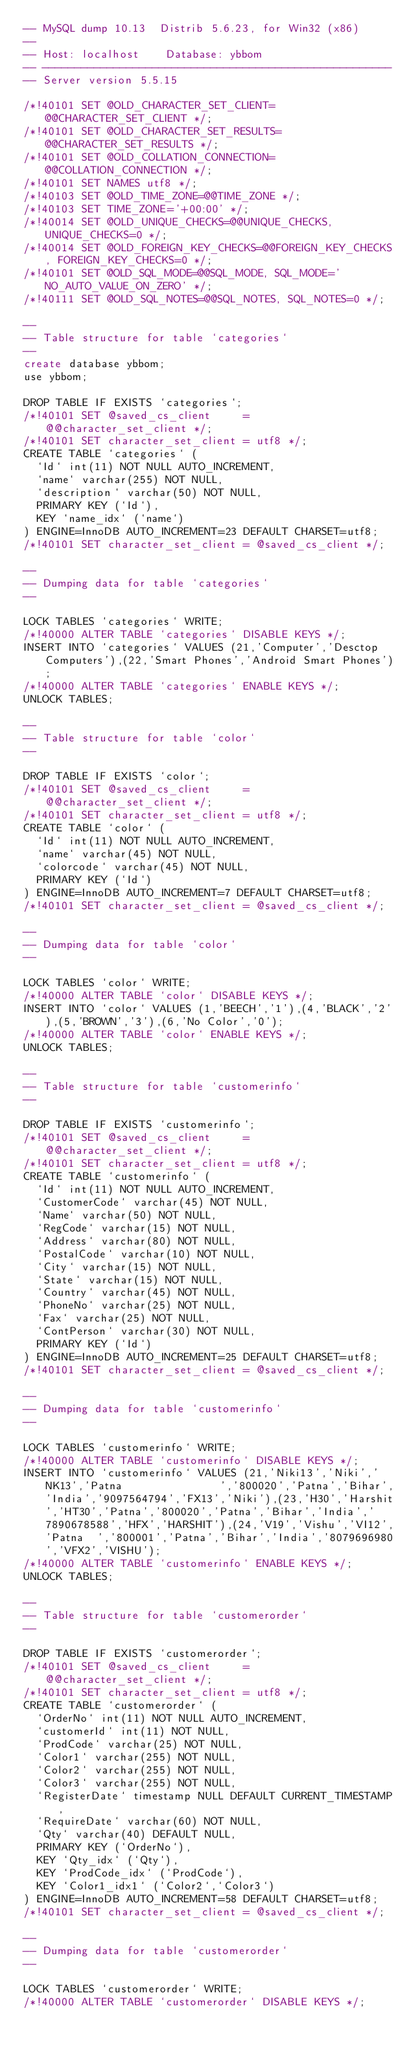<code> <loc_0><loc_0><loc_500><loc_500><_SQL_>-- MySQL dump 10.13  Distrib 5.6.23, for Win32 (x86)
--
-- Host: localhost    Database: ybbom
-- ------------------------------------------------------
-- Server version	5.5.15

/*!40101 SET @OLD_CHARACTER_SET_CLIENT=@@CHARACTER_SET_CLIENT */;
/*!40101 SET @OLD_CHARACTER_SET_RESULTS=@@CHARACTER_SET_RESULTS */;
/*!40101 SET @OLD_COLLATION_CONNECTION=@@COLLATION_CONNECTION */;
/*!40101 SET NAMES utf8 */;
/*!40103 SET @OLD_TIME_ZONE=@@TIME_ZONE */;
/*!40103 SET TIME_ZONE='+00:00' */;
/*!40014 SET @OLD_UNIQUE_CHECKS=@@UNIQUE_CHECKS, UNIQUE_CHECKS=0 */;
/*!40014 SET @OLD_FOREIGN_KEY_CHECKS=@@FOREIGN_KEY_CHECKS, FOREIGN_KEY_CHECKS=0 */;
/*!40101 SET @OLD_SQL_MODE=@@SQL_MODE, SQL_MODE='NO_AUTO_VALUE_ON_ZERO' */;
/*!40111 SET @OLD_SQL_NOTES=@@SQL_NOTES, SQL_NOTES=0 */;

--
-- Table structure for table `categories`
--
create database ybbom;
use ybbom; 

DROP TABLE IF EXISTS `categories`;
/*!40101 SET @saved_cs_client     = @@character_set_client */;
/*!40101 SET character_set_client = utf8 */;
CREATE TABLE `categories` (
  `Id` int(11) NOT NULL AUTO_INCREMENT,
  `name` varchar(255) NOT NULL,
  `description` varchar(50) NOT NULL,
  PRIMARY KEY (`Id`),
  KEY `name_idx` (`name`)
) ENGINE=InnoDB AUTO_INCREMENT=23 DEFAULT CHARSET=utf8;
/*!40101 SET character_set_client = @saved_cs_client */;

--
-- Dumping data for table `categories`
--

LOCK TABLES `categories` WRITE;
/*!40000 ALTER TABLE `categories` DISABLE KEYS */;
INSERT INTO `categories` VALUES (21,'Computer','Desctop Computers'),(22,'Smart Phones','Android Smart Phones');
/*!40000 ALTER TABLE `categories` ENABLE KEYS */;
UNLOCK TABLES;

--
-- Table structure for table `color`
--

DROP TABLE IF EXISTS `color`;
/*!40101 SET @saved_cs_client     = @@character_set_client */;
/*!40101 SET character_set_client = utf8 */;
CREATE TABLE `color` (
  `Id` int(11) NOT NULL AUTO_INCREMENT,
  `name` varchar(45) NOT NULL,
  `colorcode` varchar(45) NOT NULL,
  PRIMARY KEY (`Id`)
) ENGINE=InnoDB AUTO_INCREMENT=7 DEFAULT CHARSET=utf8;
/*!40101 SET character_set_client = @saved_cs_client */;

--
-- Dumping data for table `color`
--

LOCK TABLES `color` WRITE;
/*!40000 ALTER TABLE `color` DISABLE KEYS */;
INSERT INTO `color` VALUES (1,'BEECH','1'),(4,'BLACK','2'),(5,'BROWN','3'),(6,'No Color','0');
/*!40000 ALTER TABLE `color` ENABLE KEYS */;
UNLOCK TABLES;

--
-- Table structure for table `customerinfo`
--

DROP TABLE IF EXISTS `customerinfo`;
/*!40101 SET @saved_cs_client     = @@character_set_client */;
/*!40101 SET character_set_client = utf8 */;
CREATE TABLE `customerinfo` (
  `Id` int(11) NOT NULL AUTO_INCREMENT,
  `CustomerCode` varchar(45) NOT NULL,
  `Name` varchar(50) NOT NULL,
  `RegCode` varchar(15) NOT NULL,
  `Address` varchar(80) NOT NULL,
  `PostalCode` varchar(10) NOT NULL,
  `City` varchar(15) NOT NULL,
  `State` varchar(15) NOT NULL,
  `Country` varchar(45) NOT NULL,
  `PhoneNo` varchar(25) NOT NULL,
  `Fax` varchar(25) NOT NULL,
  `ContPerson` varchar(30) NOT NULL,
  PRIMARY KEY (`Id`)
) ENGINE=InnoDB AUTO_INCREMENT=25 DEFAULT CHARSET=utf8;
/*!40101 SET character_set_client = @saved_cs_client */;

--
-- Dumping data for table `customerinfo`
--

LOCK TABLES `customerinfo` WRITE;
/*!40000 ALTER TABLE `customerinfo` DISABLE KEYS */;
INSERT INTO `customerinfo` VALUES (21,'Niki13','Niki','NK13','Patna								','800020','Patna','Bihar','India','9097564794','FX13','Niki'),(23,'H30','Harshit','HT30','Patna','800020','Patna','Bihar','India','7890678588','HFX','HARSHIT'),(24,'V19','Vishu','VI12','Patna	','800001','Patna','Bihar','India','8079696980','VFX2','VISHU');
/*!40000 ALTER TABLE `customerinfo` ENABLE KEYS */;
UNLOCK TABLES;

--
-- Table structure for table `customerorder`
--

DROP TABLE IF EXISTS `customerorder`;
/*!40101 SET @saved_cs_client     = @@character_set_client */;
/*!40101 SET character_set_client = utf8 */;
CREATE TABLE `customerorder` (
  `OrderNo` int(11) NOT NULL AUTO_INCREMENT,
  `customerId` int(11) NOT NULL,
  `ProdCode` varchar(25) NOT NULL,
  `Color1` varchar(255) NOT NULL,
  `Color2` varchar(255) NOT NULL,
  `Color3` varchar(255) NOT NULL,
  `RegisterDate` timestamp NULL DEFAULT CURRENT_TIMESTAMP,
  `RequireDate` varchar(60) NOT NULL,
  `Qty` varchar(40) DEFAULT NULL,
  PRIMARY KEY (`OrderNo`),
  KEY `Qty_idx` (`Qty`),
  KEY `ProdCode_idx` (`ProdCode`),
  KEY `Color1_idx1` (`Color2`,`Color3`)
) ENGINE=InnoDB AUTO_INCREMENT=58 DEFAULT CHARSET=utf8;
/*!40101 SET character_set_client = @saved_cs_client */;

--
-- Dumping data for table `customerorder`
--

LOCK TABLES `customerorder` WRITE;
/*!40000 ALTER TABLE `customerorder` DISABLE KEYS */;</code> 